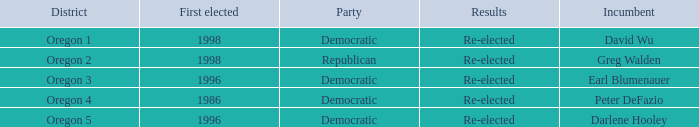Which Democratic incumbent was first elected in 1998? David Wu. 